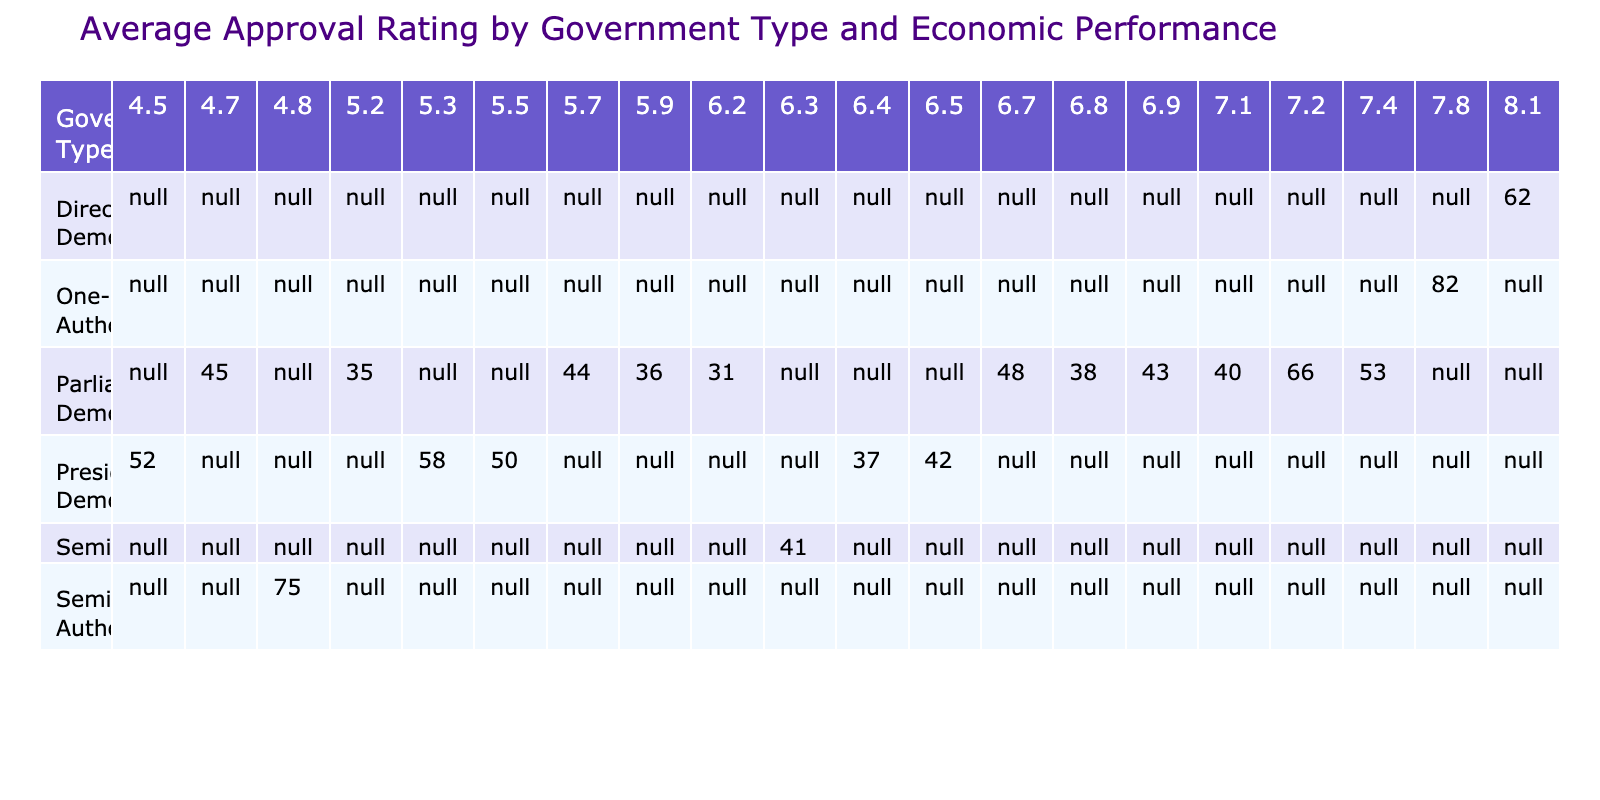What is the approval rating of China's leader? The table shows the approval ratings for various leaders across different government types. According to the data for China, Xi Jinping has an approval rating of 82.
Answer: 82 What government type has the highest average approval rating? To determine this, we need to look at the average approval ratings across each government type listed in the table. The average for One-Party Authoritarian (which includes only China) is 82, the highest among other government types.
Answer: One-Party Authoritarian Which government type has the lowest average approval rating based on the table? By comparing the approval ratings for each government type, we can see that within the data provided, Parliamentary Democracy has several lower values like 31 (Israel) and 35 (UK), leading to its lowest average rating compared to the others.
Answer: Parliamentary Democracy What is the average approval rating for leaders in Presidential Democracies? To find the average for Presidential Democracies, we take the approval ratings: 42 (US), 50 (Brazil), 52 (Turkey), 58 (Mexico), and 37 (South Korea). Summing these gives us 239. There are 5 data points, so the average is 239 divided by 5, which is 47.8.
Answer: 47.8 Is it true that all leaders in Parliamentary Democracy have an approval rating above 40? We need to evaluate the listed approval ratings under Parliamentary Democracy. From the data, Israel's leader has an approval rating of 31, which is below 40. Thus, not all leaders in this category have ratings above 40.
Answer: No Which country's economic performance rating is highest among the leaders with an approval rating of over 50? Looking at the table, the only leader with an approval rating over 50 is Xi Jinping with 82 and has an economic performance rating of 7.8, compared to Turkey at 4.5 and Mexico at 5.3, so Xi's is indeed the highest.
Answer: China How many government types have an average approval rating above 50? The task involves examining the table entries. We have One-Party Authoritarian (China with 82), Semi-Presidential Authoritarian (Russia with 75), and Semi-Presidential (France with 41 but not above 50). Only the first two types meet the criterion, indicating only 2 types exceed this average.
Answer: 2 Which leader has the highest foreign policy rating and what is it? In the table, reviewing foreign policy ratings indicates that Xi Jinping has a foreign policy rating of 7.5, which is the highest in the data provided.
Answer: 7.5 What is the average domestic policy rating of leaders in Parliamentary Democracies? To find the average, we sum the domestic policy ratings: 4.5 (Israel), 4.9 (UK), 5.6 (Japan), 5.3 (South Africa), 6.4 (Canada), 6.9 (Australia), 7.5 (India), and 5.8 (Italy) which totals 46.9. Dividing this sum by the number of leaders (8), we find the average is 5.86.
Answer: 5.86 